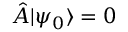<formula> <loc_0><loc_0><loc_500><loc_500>\hat { A } | \psi _ { 0 } \rangle = 0</formula> 